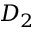Convert formula to latex. <formula><loc_0><loc_0><loc_500><loc_500>D _ { 2 }</formula> 